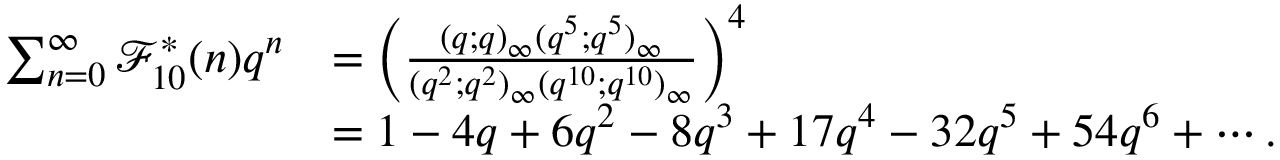<formula> <loc_0><loc_0><loc_500><loc_500>\begin{array} { r l } { \sum _ { n = 0 } ^ { \infty } \mathcal { F } _ { 1 0 } ^ { * } ( n ) q ^ { n } } & { = \left ( \frac { ( q ; q ) _ { \infty } ( q ^ { 5 } ; q ^ { 5 } ) _ { \infty } } { ( q ^ { 2 } ; q ^ { 2 } ) _ { \infty } ( q ^ { 1 0 } ; q ^ { 1 0 } ) _ { \infty } } \right ) ^ { 4 } } \\ & { = 1 - 4 q + 6 q ^ { 2 } - 8 q ^ { 3 } + 1 7 q ^ { 4 } - 3 2 q ^ { 5 } + 5 4 q ^ { 6 } + \cdots . } \end{array}</formula> 